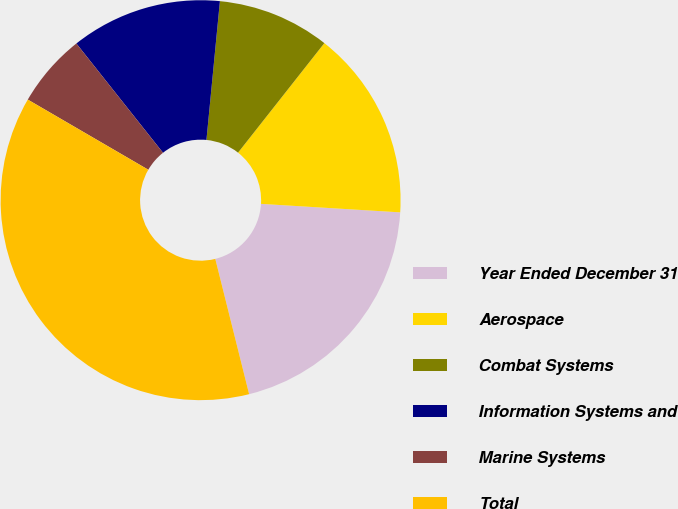Convert chart to OTSL. <chart><loc_0><loc_0><loc_500><loc_500><pie_chart><fcel>Year Ended December 31<fcel>Aerospace<fcel>Combat Systems<fcel>Information Systems and<fcel>Marine Systems<fcel>Total<nl><fcel>20.13%<fcel>15.35%<fcel>9.08%<fcel>12.21%<fcel>5.94%<fcel>37.29%<nl></chart> 